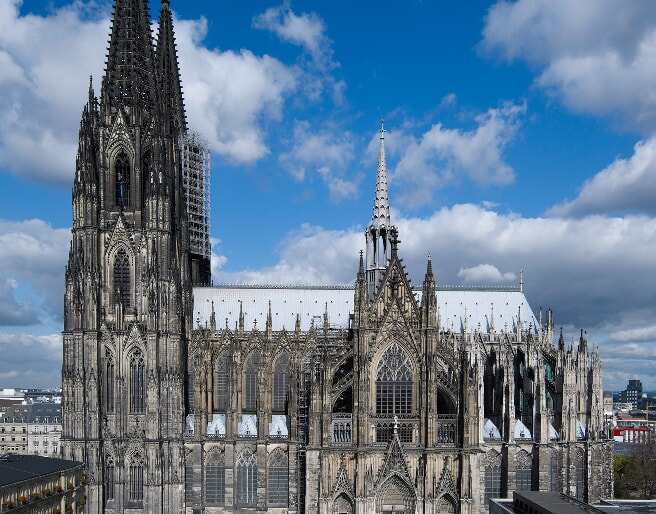Analyze the image in a comprehensive and detailed manner. The image captures the majestic Cologne Cathedral, a renowned landmark in Cologne, Germany. The cathedral, constructed from dark stone, stands tall against the backdrop of a clear blue sky dotted with white clouds. The photograph is taken from a high vantage point, offering a comprehensive view of the cathedral's architectural grandeur. The cathedral's intricate details are clearly visible, including its pointed arches, flying buttresses, and ornate spires that reach towards the sky. In the distance, the surrounding buildings of Cologne provide a contrasting backdrop to the cathedral's Gothic magnificence. The image is a testament to the cathedral's imposing presence and the intricate craftsmanship of its architecture. 